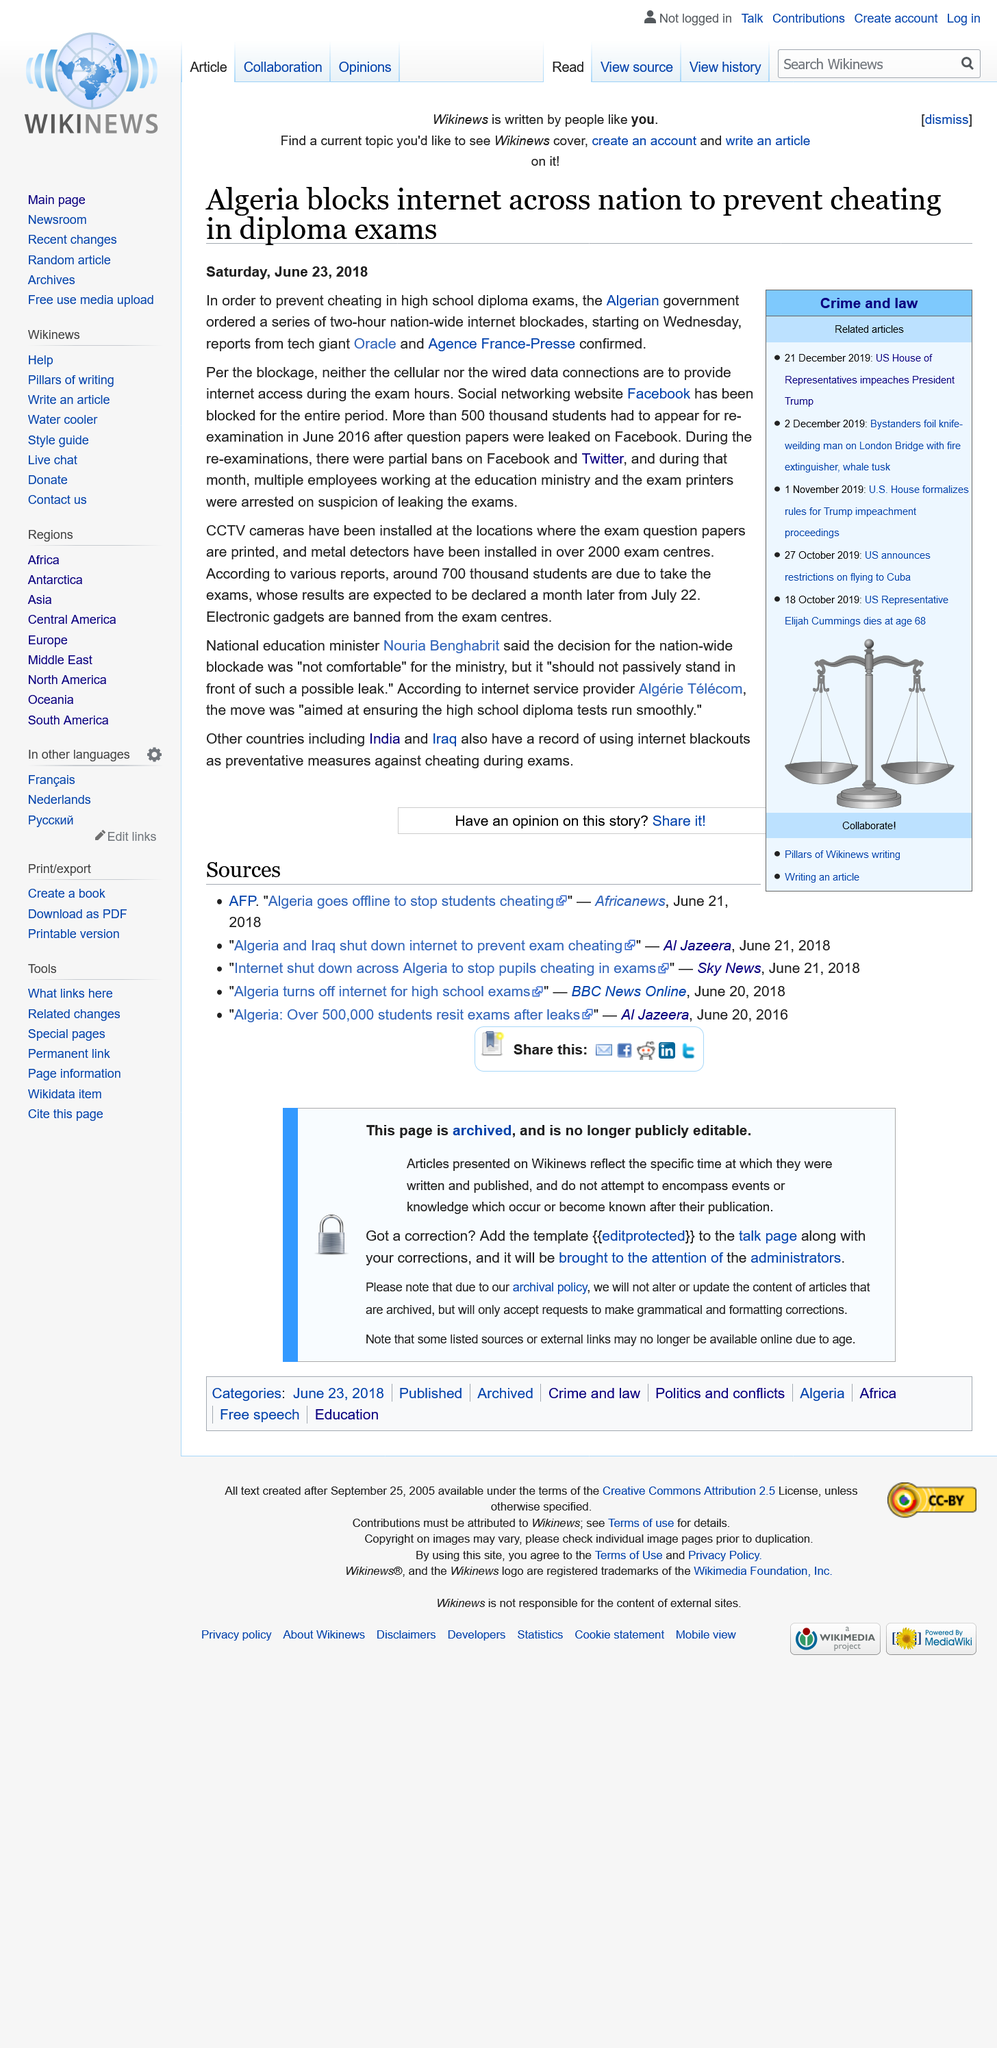Outline some significant characteristics in this image. The government of Algeria has ordered an internet blockade. In June 2016, over 500 thousand students were required to be re-examined. The internet blockade is set to begin on Wednesday, June 27th, 2018. 